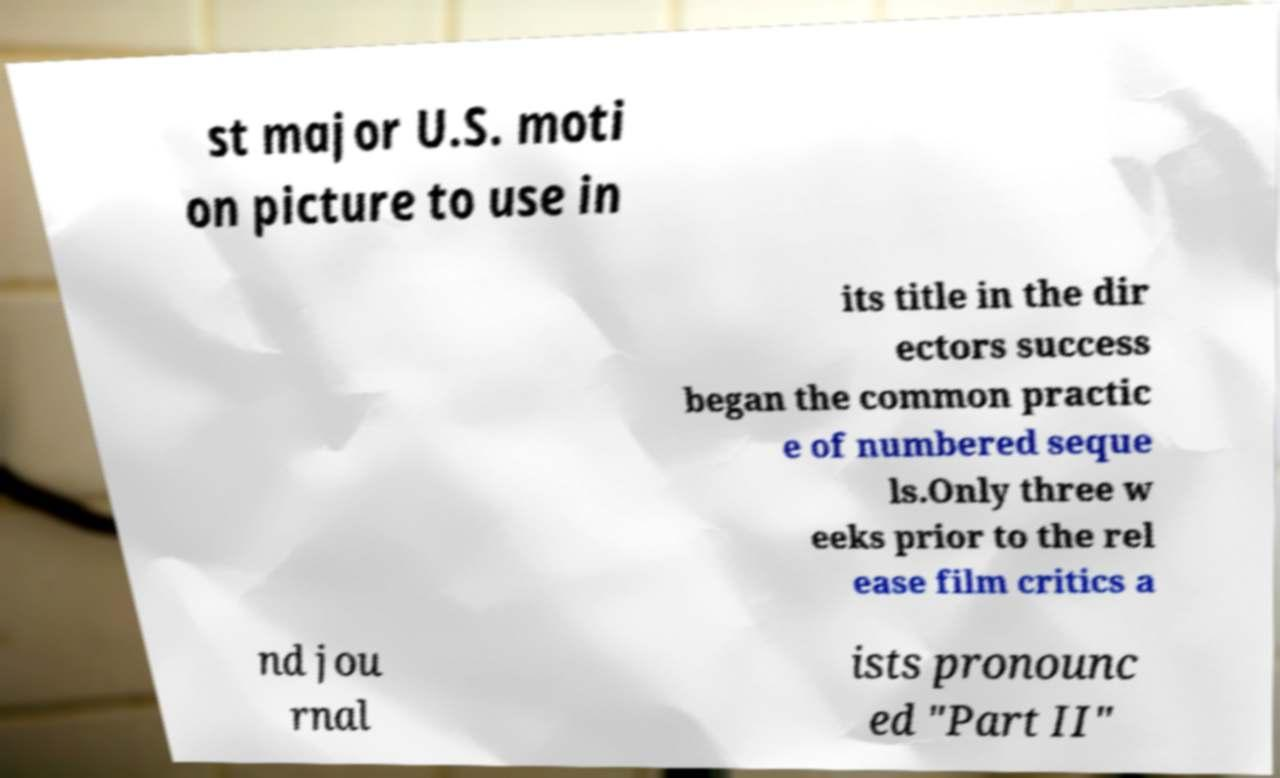Could you extract and type out the text from this image? st major U.S. moti on picture to use in its title in the dir ectors success began the common practic e of numbered seque ls.Only three w eeks prior to the rel ease film critics a nd jou rnal ists pronounc ed "Part II" 